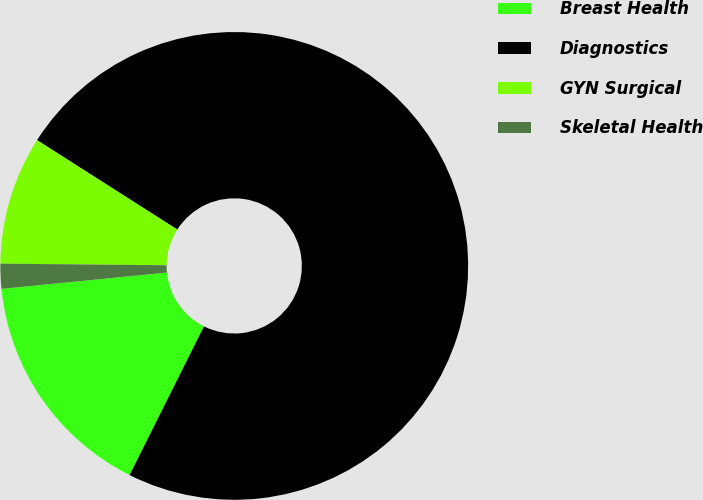Convert chart to OTSL. <chart><loc_0><loc_0><loc_500><loc_500><pie_chart><fcel>Breast Health<fcel>Diagnostics<fcel>GYN Surgical<fcel>Skeletal Health<nl><fcel>16.05%<fcel>73.35%<fcel>8.88%<fcel>1.72%<nl></chart> 